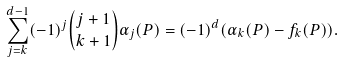<formula> <loc_0><loc_0><loc_500><loc_500>\sum _ { j = k } ^ { d - 1 } ( - 1 ) ^ { j } { j + 1 \choose k + 1 } \alpha _ { j } ( P ) = ( - 1 ) ^ { d } ( \alpha _ { k } ( P ) - f _ { k } ( P ) ) .</formula> 